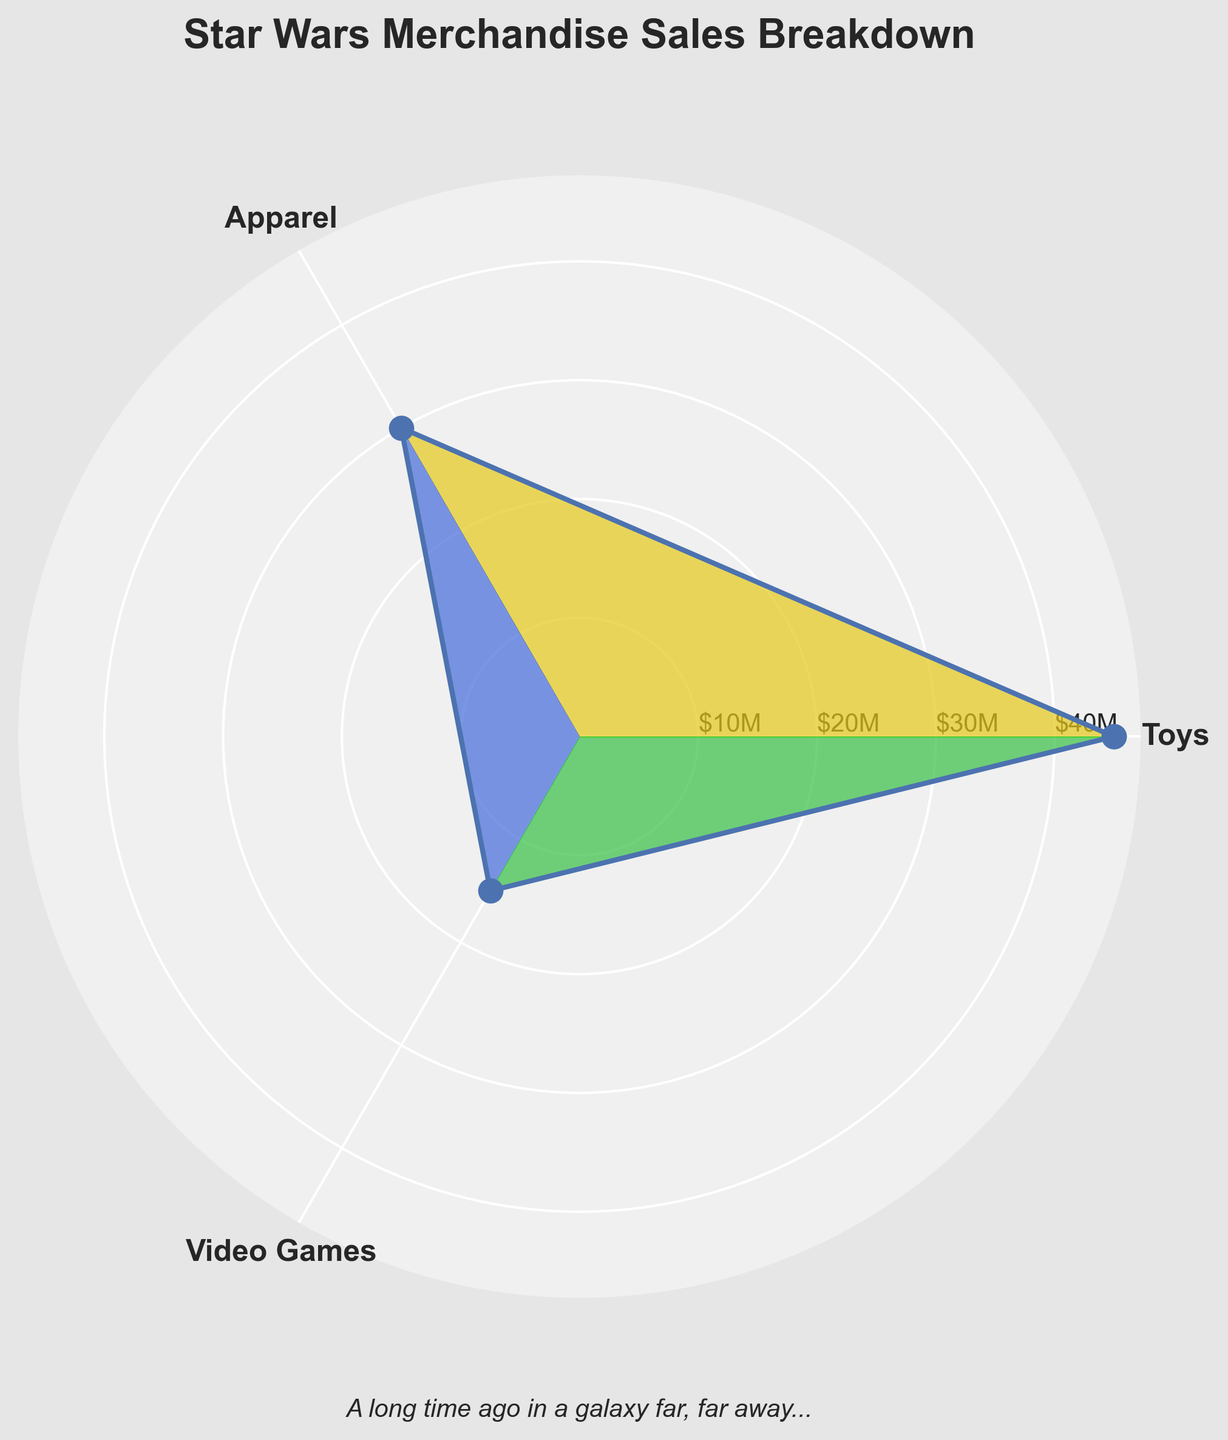What is the title of the figure? The title is usually placed at the top of the chart and provides a brief description of what the figure represents. In this case, it should be about Star Wars merchandise sales.
Answer: Star Wars Merchandise Sales Breakdown How many categories are there in the figure? By observing the labels on the chart's axes, we can count the number of distinct labels representing different categories.
Answer: 3 Which category has the highest sales? By looking at the lengths of the data points or segments in the rose chart, the category with the longest segment represents the highest sales.
Answer: Toys Which category has the lowest sales? By observing the segments in the rose chart, the category with the shortest segment represents the lowest sales.
Answer: Video Games What are the colors used to represent each category? The plot uses specific colors for each segment. By distinguishing the segments visually, we can identify the different colors assigned to each category.
Answer: Toys: Gold, Apparel: Blue, Video Games: Green How much more did Toys sell compared to Apparel? To find the difference in sales between Toys and Apparel, subtract the sales amount of Apparel from Toys. Based on the visual representation, Toys are shown to have higher sales.
Answer: $15 million What is the average sales amount across all categories? To get the average, sum up the sales amounts of all categories and divide by the number of categories. The total sales are $45M (Toys) + $30M (Apparel) + $15M (Video Games) = $90M. The average is $90M / 3 categories.
Answer: $30 million Is the sales amount of Video Games less than half of the sales amount of Toys? To check if Video Games sales are less than half of Toys, first calculate half of Toys' sales amount (which is $22.5M), and then compare it with Video Games' sales amount (which is $15M).
Answer: Yes What is the total sales amount for Apparel and Video Games combined? By adding the sales amounts of Apparel ($30M) and Video Games ($15M), we get the combined total sales amount.
Answer: $45 million How is the color used to enhance the visual appeal of the figure? Different colors are used to represent each category, making it easier to distinguish between them and enhancing the visual appeal and clarity of the data presentation.
Answer: Unique colors for each category 